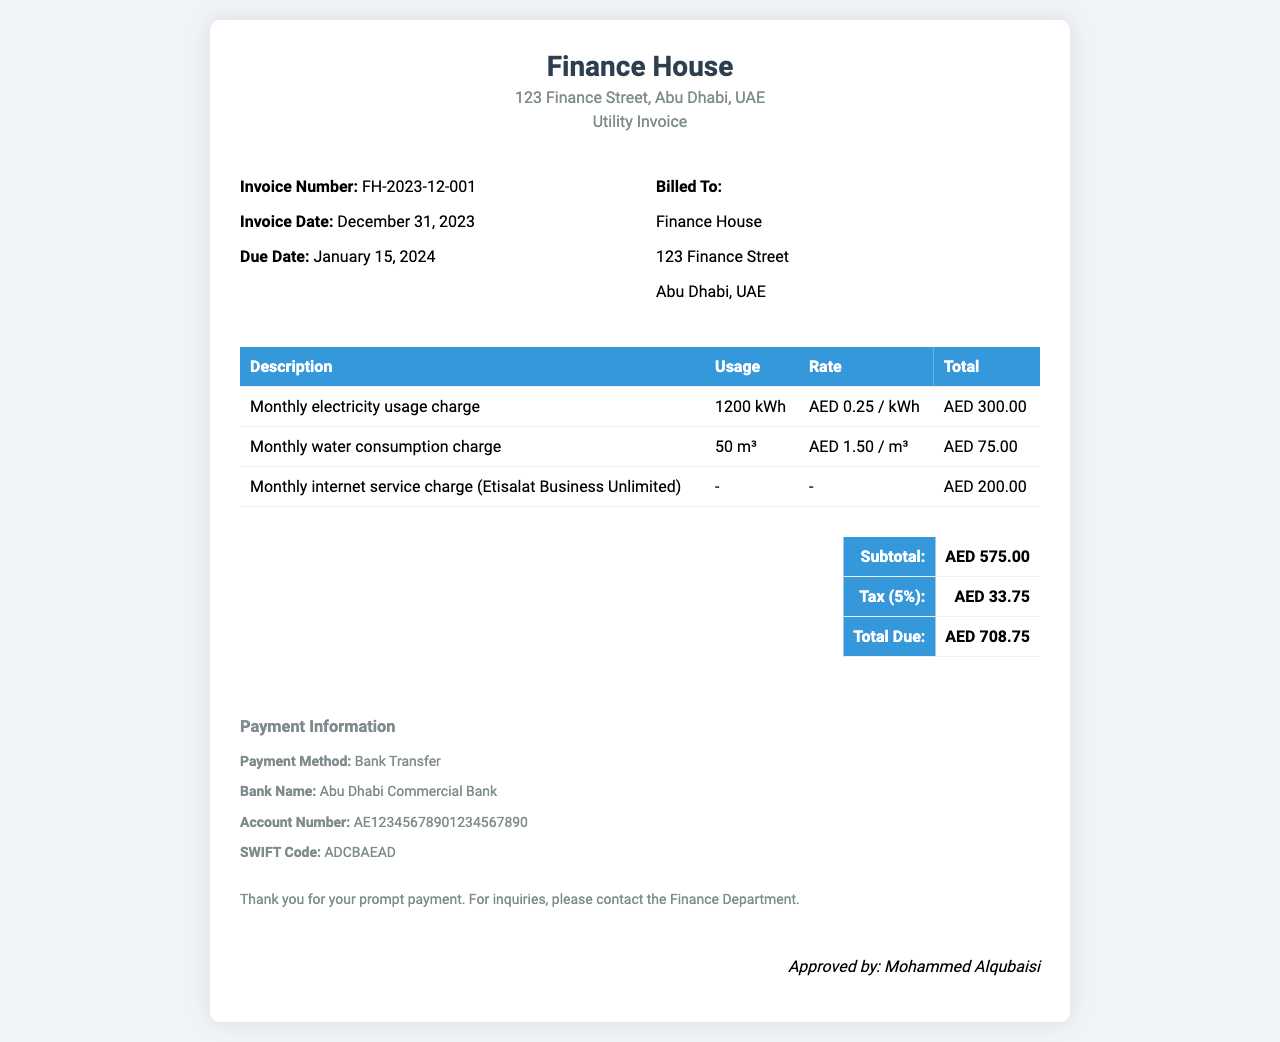What is the invoice number? The invoice number is displayed prominently in the invoice details section.
Answer: FH-2023-12-001 What is the total due amount? The total due amount is calculated from the subtotal and tax presented in the total section.
Answer: AED 708.75 What is the rate for electricity usage? The rate for electricity usage is specified per kilowatt-hour in the table section.
Answer: AED 0.25 / kWh What is the due date for the invoice? The due date can be found in the invoice details section, often indicated clearly.
Answer: January 15, 2024 What is the tax percentage applied? The tax percentage is mentioned in the total section of the invoice.
Answer: 5% How much was spent on water consumption? The amount spent on water consumption is detailed with its usage and rate in the table.
Answer: AED 75.00 What is the payment method mentioned? The payment method is listed in the payment information section of the invoice.
Answer: Bank Transfer Who approved the invoice? The name of the person who approved the invoice is found at the bottom of the document.
Answer: Mohammed Alqubaisi What is the subtotal before tax? The subtotal is the total before tax and is clearly indicated in the total section.
Answer: AED 575.00 